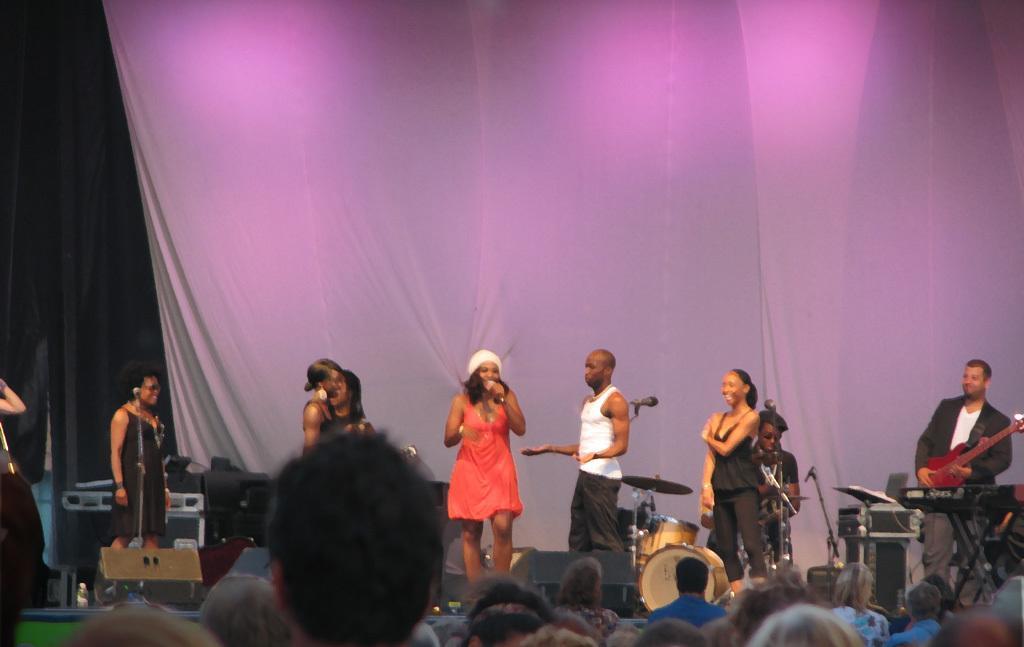Could you give a brief overview of what you see in this image? In this image I can see there are few persons holding a musical instrument and playing a music and at the bottom I can see person head and at the top I can see the white color curtain. 